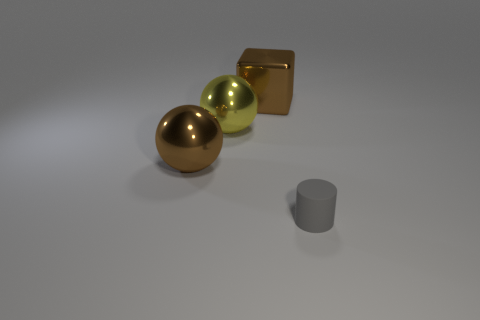Are there any indications of scale or size for these objects? Without a reference object of known size, it's challenging to determine the exact scale, but relative to each other, the spheres and cube suggest a modest size, whereas the cylinder appears smaller in height and width. 